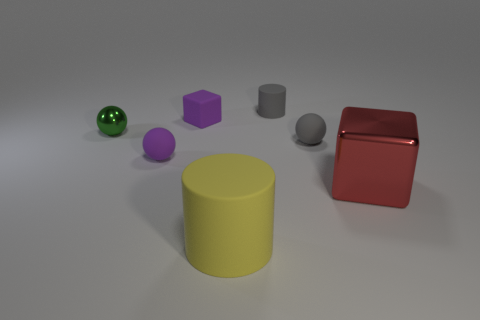What number of other objects are there of the same size as the purple rubber block?
Your answer should be very brief. 4. There is a gray ball; are there any small things on the right side of it?
Offer a terse response. No. Does the shiny cube have the same color as the small matte thing that is in front of the gray rubber sphere?
Offer a very short reply. No. There is a thing in front of the metal object that is to the right of the small gray rubber object behind the small purple cube; what is its color?
Your answer should be very brief. Yellow. Is there a large yellow matte thing that has the same shape as the green shiny object?
Ensure brevity in your answer.  No. There is a rubber thing that is the same size as the red cube; what color is it?
Give a very brief answer. Yellow. There is a block that is in front of the tiny metallic sphere; what is it made of?
Give a very brief answer. Metal. There is a metal object to the left of the big rubber object; is it the same shape as the tiny purple object that is behind the small gray sphere?
Your answer should be very brief. No. Are there the same number of big rubber things behind the big yellow object and small purple things?
Offer a terse response. No. What number of small things are made of the same material as the gray cylinder?
Your answer should be compact. 3. 